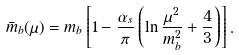<formula> <loc_0><loc_0><loc_500><loc_500>\bar { m } _ { b } ( \mu ) = m _ { b } \left [ 1 - \frac { \alpha _ { s } } { \pi } \left ( \ln \frac { \mu ^ { 2 } } { m ^ { 2 } _ { b } } + \frac { 4 } { 3 } \right ) \right ] .</formula> 